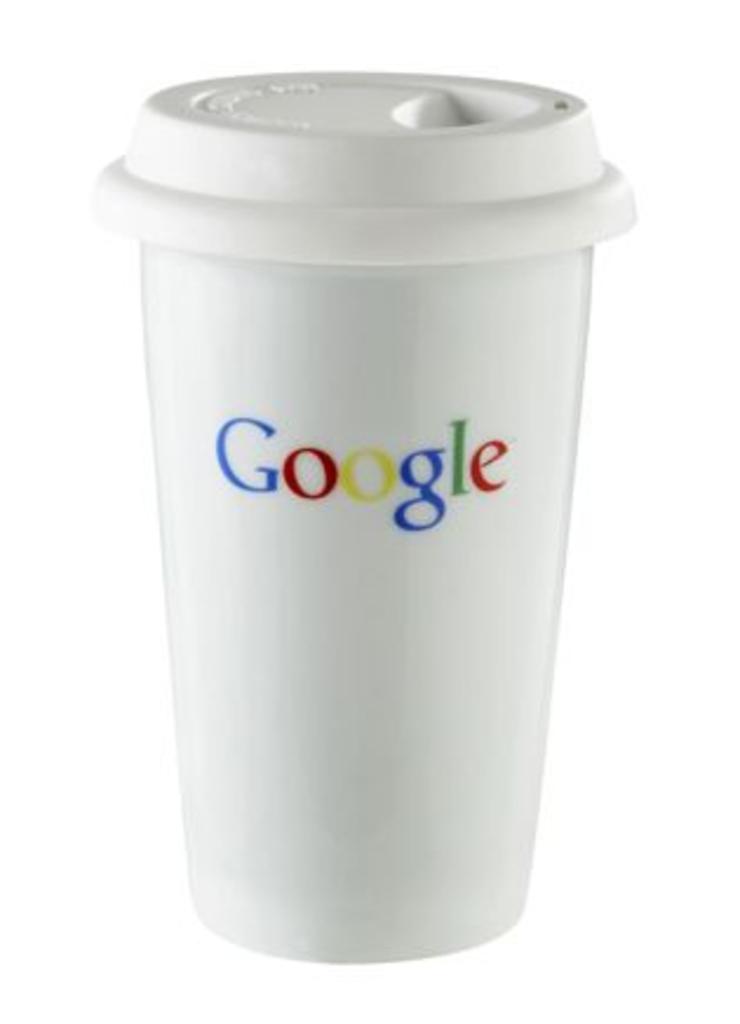What brand is on the cup?
Your answer should be compact. Google. 